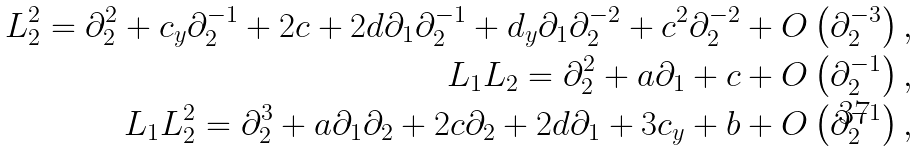<formula> <loc_0><loc_0><loc_500><loc_500>L _ { 2 } ^ { 2 } = \partial _ { 2 } ^ { 2 } + c _ { y } \partial _ { 2 } ^ { - 1 } + 2 c + 2 d \partial _ { 1 } \partial _ { 2 } ^ { - 1 } + d _ { y } \partial _ { 1 } \partial _ { 2 } ^ { - 2 } + c ^ { 2 } \partial _ { 2 } ^ { - 2 } + O \left ( \partial _ { 2 } ^ { - 3 } \right ) , \\ L _ { 1 } L _ { 2 } = \partial _ { 2 } ^ { 2 } + a \partial _ { 1 } + c + O \left ( \partial _ { 2 } ^ { - 1 } \right ) , \\ L _ { 1 } L _ { 2 } ^ { 2 } = \partial _ { 2 } ^ { 3 } + a \partial _ { 1 } \partial _ { 2 } + 2 c \partial _ { 2 } + 2 d \partial _ { 1 } + 3 c _ { y } + b + O \left ( \partial _ { 2 } ^ { - 1 } \right ) ,</formula> 